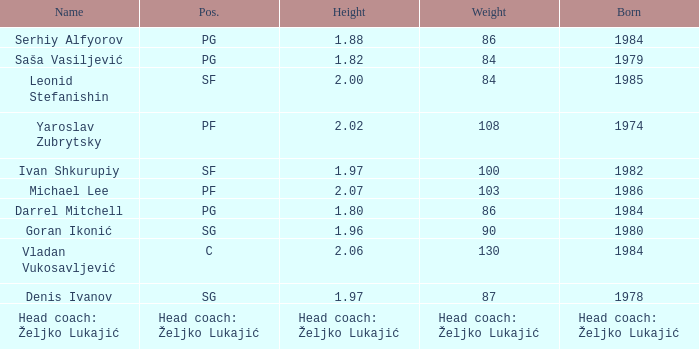How much did serhiy alfyorov's weight measure? 86.0. 